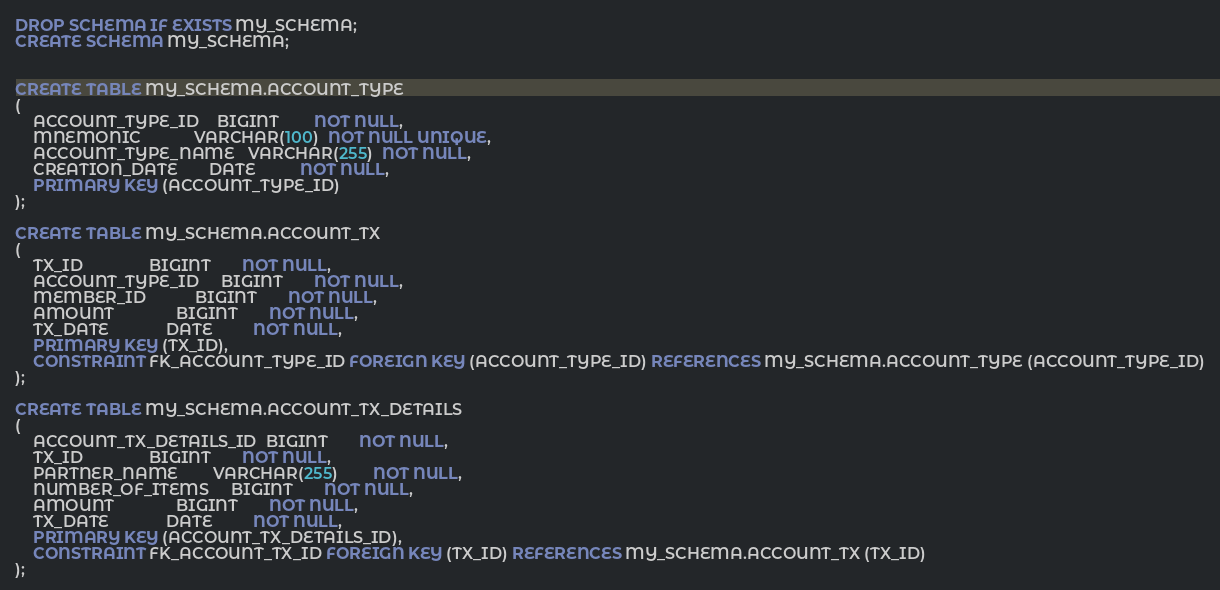Convert code to text. <code><loc_0><loc_0><loc_500><loc_500><_SQL_>
DROP SCHEMA IF EXISTS MY_SCHEMA;
CREATE SCHEMA MY_SCHEMA;


CREATE TABLE MY_SCHEMA.ACCOUNT_TYPE
(
    ACCOUNT_TYPE_ID    BIGINT        NOT NULL,
    MNEMONIC            VARCHAR(100)  NOT NULL UNIQUE,
    ACCOUNT_TYPE_NAME   VARCHAR(255)  NOT NULL,
    CREATION_DATE       DATE          NOT NULL,
    PRIMARY KEY (ACCOUNT_TYPE_ID)
);

CREATE TABLE MY_SCHEMA.ACCOUNT_TX
(
    TX_ID               BIGINT       NOT NULL,
    ACCOUNT_TYPE_ID     BIGINT       NOT NULL,
    MEMBER_ID           BIGINT       NOT NULL,
    AMOUNT              BIGINT       NOT NULL,
    TX_DATE             DATE         NOT NULL,
    PRIMARY KEY (TX_ID),
    CONSTRAINT FK_ACCOUNT_TYPE_ID FOREIGN KEY (ACCOUNT_TYPE_ID) REFERENCES MY_SCHEMA.ACCOUNT_TYPE (ACCOUNT_TYPE_ID)
);

CREATE TABLE MY_SCHEMA.ACCOUNT_TX_DETAILS
(
    ACCOUNT_TX_DETAILS_ID  BIGINT       NOT NULL,
    TX_ID               BIGINT       NOT NULL,
    PARTNER_NAME        VARCHAR(255)        NOT NULL,
    NUMBER_OF_ITEMS     BIGINT       NOT NULL,
    AMOUNT              BIGINT       NOT NULL,
    TX_DATE             DATE         NOT NULL,
    PRIMARY KEY (ACCOUNT_TX_DETAILS_ID),
    CONSTRAINT FK_ACCOUNT_TX_ID FOREIGN KEY (TX_ID) REFERENCES MY_SCHEMA.ACCOUNT_TX (TX_ID)
);</code> 